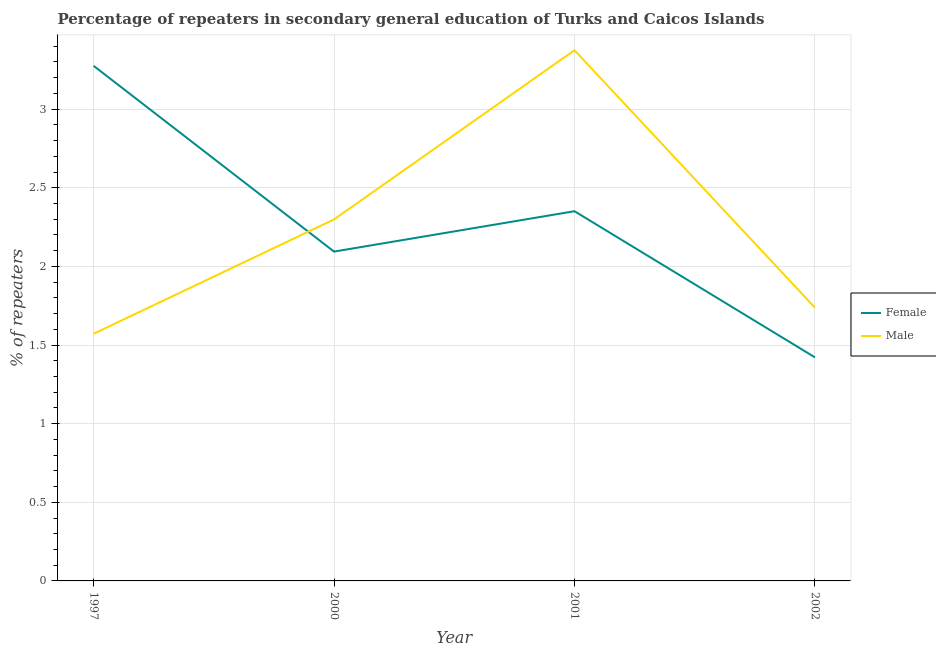What is the percentage of male repeaters in 2002?
Give a very brief answer. 1.74. Across all years, what is the maximum percentage of female repeaters?
Offer a terse response. 3.28. Across all years, what is the minimum percentage of female repeaters?
Provide a short and direct response. 1.42. In which year was the percentage of female repeaters minimum?
Provide a short and direct response. 2002. What is the total percentage of male repeaters in the graph?
Provide a succinct answer. 8.98. What is the difference between the percentage of male repeaters in 2000 and that in 2002?
Provide a short and direct response. 0.56. What is the difference between the percentage of female repeaters in 2001 and the percentage of male repeaters in 2000?
Provide a succinct answer. 0.05. What is the average percentage of male repeaters per year?
Keep it short and to the point. 2.25. In the year 2002, what is the difference between the percentage of male repeaters and percentage of female repeaters?
Offer a terse response. 0.32. In how many years, is the percentage of male repeaters greater than 2.9 %?
Give a very brief answer. 1. What is the ratio of the percentage of male repeaters in 1997 to that in 2002?
Your answer should be compact. 0.9. What is the difference between the highest and the second highest percentage of female repeaters?
Your answer should be very brief. 0.92. What is the difference between the highest and the lowest percentage of male repeaters?
Your answer should be very brief. 1.8. In how many years, is the percentage of female repeaters greater than the average percentage of female repeaters taken over all years?
Provide a short and direct response. 2. Is the percentage of female repeaters strictly greater than the percentage of male repeaters over the years?
Give a very brief answer. No. How many lines are there?
Provide a short and direct response. 2. How many years are there in the graph?
Your answer should be very brief. 4. What is the difference between two consecutive major ticks on the Y-axis?
Your response must be concise. 0.5. Does the graph contain grids?
Provide a short and direct response. Yes. Where does the legend appear in the graph?
Provide a short and direct response. Center right. What is the title of the graph?
Ensure brevity in your answer.  Percentage of repeaters in secondary general education of Turks and Caicos Islands. What is the label or title of the X-axis?
Offer a terse response. Year. What is the label or title of the Y-axis?
Your answer should be very brief. % of repeaters. What is the % of repeaters of Female in 1997?
Make the answer very short. 3.28. What is the % of repeaters of Male in 1997?
Make the answer very short. 1.57. What is the % of repeaters of Female in 2000?
Provide a succinct answer. 2.09. What is the % of repeaters in Male in 2000?
Your response must be concise. 2.3. What is the % of repeaters in Female in 2001?
Your answer should be very brief. 2.35. What is the % of repeaters in Male in 2001?
Make the answer very short. 3.37. What is the % of repeaters of Female in 2002?
Your answer should be very brief. 1.42. What is the % of repeaters in Male in 2002?
Make the answer very short. 1.74. Across all years, what is the maximum % of repeaters in Female?
Make the answer very short. 3.28. Across all years, what is the maximum % of repeaters in Male?
Keep it short and to the point. 3.37. Across all years, what is the minimum % of repeaters in Female?
Ensure brevity in your answer.  1.42. Across all years, what is the minimum % of repeaters of Male?
Your answer should be compact. 1.57. What is the total % of repeaters of Female in the graph?
Your response must be concise. 9.14. What is the total % of repeaters of Male in the graph?
Make the answer very short. 8.98. What is the difference between the % of repeaters in Female in 1997 and that in 2000?
Offer a very short reply. 1.18. What is the difference between the % of repeaters of Male in 1997 and that in 2000?
Give a very brief answer. -0.73. What is the difference between the % of repeaters of Female in 1997 and that in 2001?
Make the answer very short. 0.92. What is the difference between the % of repeaters of Male in 1997 and that in 2001?
Your answer should be compact. -1.8. What is the difference between the % of repeaters of Female in 1997 and that in 2002?
Offer a very short reply. 1.85. What is the difference between the % of repeaters in Male in 1997 and that in 2002?
Provide a succinct answer. -0.17. What is the difference between the % of repeaters in Female in 2000 and that in 2001?
Offer a very short reply. -0.26. What is the difference between the % of repeaters of Male in 2000 and that in 2001?
Ensure brevity in your answer.  -1.08. What is the difference between the % of repeaters of Female in 2000 and that in 2002?
Ensure brevity in your answer.  0.67. What is the difference between the % of repeaters in Male in 2000 and that in 2002?
Offer a terse response. 0.56. What is the difference between the % of repeaters of Female in 2001 and that in 2002?
Provide a short and direct response. 0.93. What is the difference between the % of repeaters of Male in 2001 and that in 2002?
Provide a succinct answer. 1.64. What is the difference between the % of repeaters in Female in 1997 and the % of repeaters in Male in 2000?
Provide a short and direct response. 0.98. What is the difference between the % of repeaters in Female in 1997 and the % of repeaters in Male in 2001?
Provide a short and direct response. -0.1. What is the difference between the % of repeaters of Female in 1997 and the % of repeaters of Male in 2002?
Make the answer very short. 1.54. What is the difference between the % of repeaters in Female in 2000 and the % of repeaters in Male in 2001?
Your answer should be very brief. -1.28. What is the difference between the % of repeaters in Female in 2000 and the % of repeaters in Male in 2002?
Your answer should be compact. 0.36. What is the difference between the % of repeaters of Female in 2001 and the % of repeaters of Male in 2002?
Provide a succinct answer. 0.61. What is the average % of repeaters of Female per year?
Ensure brevity in your answer.  2.29. What is the average % of repeaters of Male per year?
Your response must be concise. 2.25. In the year 1997, what is the difference between the % of repeaters in Female and % of repeaters in Male?
Offer a terse response. 1.7. In the year 2000, what is the difference between the % of repeaters in Female and % of repeaters in Male?
Your answer should be compact. -0.2. In the year 2001, what is the difference between the % of repeaters of Female and % of repeaters of Male?
Offer a terse response. -1.02. In the year 2002, what is the difference between the % of repeaters in Female and % of repeaters in Male?
Your answer should be very brief. -0.32. What is the ratio of the % of repeaters of Female in 1997 to that in 2000?
Provide a succinct answer. 1.56. What is the ratio of the % of repeaters in Male in 1997 to that in 2000?
Make the answer very short. 0.68. What is the ratio of the % of repeaters in Female in 1997 to that in 2001?
Make the answer very short. 1.39. What is the ratio of the % of repeaters in Male in 1997 to that in 2001?
Your response must be concise. 0.47. What is the ratio of the % of repeaters in Female in 1997 to that in 2002?
Offer a very short reply. 2.3. What is the ratio of the % of repeaters of Male in 1997 to that in 2002?
Give a very brief answer. 0.9. What is the ratio of the % of repeaters in Female in 2000 to that in 2001?
Provide a succinct answer. 0.89. What is the ratio of the % of repeaters of Male in 2000 to that in 2001?
Offer a terse response. 0.68. What is the ratio of the % of repeaters of Female in 2000 to that in 2002?
Your answer should be very brief. 1.47. What is the ratio of the % of repeaters in Male in 2000 to that in 2002?
Provide a short and direct response. 1.32. What is the ratio of the % of repeaters of Female in 2001 to that in 2002?
Your answer should be compact. 1.65. What is the ratio of the % of repeaters in Male in 2001 to that in 2002?
Your answer should be compact. 1.94. What is the difference between the highest and the second highest % of repeaters in Female?
Ensure brevity in your answer.  0.92. What is the difference between the highest and the second highest % of repeaters in Male?
Give a very brief answer. 1.08. What is the difference between the highest and the lowest % of repeaters in Female?
Provide a succinct answer. 1.85. What is the difference between the highest and the lowest % of repeaters in Male?
Your answer should be compact. 1.8. 